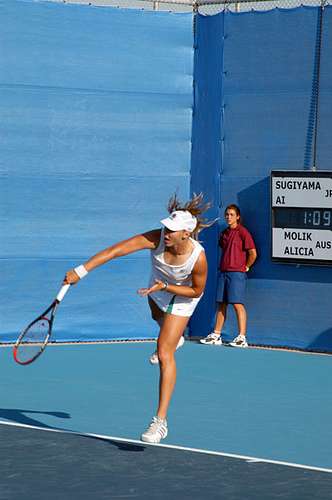Please identify all text content in this image. SUGIYAMA AI MOLIK ALICIA AUS 09 I 